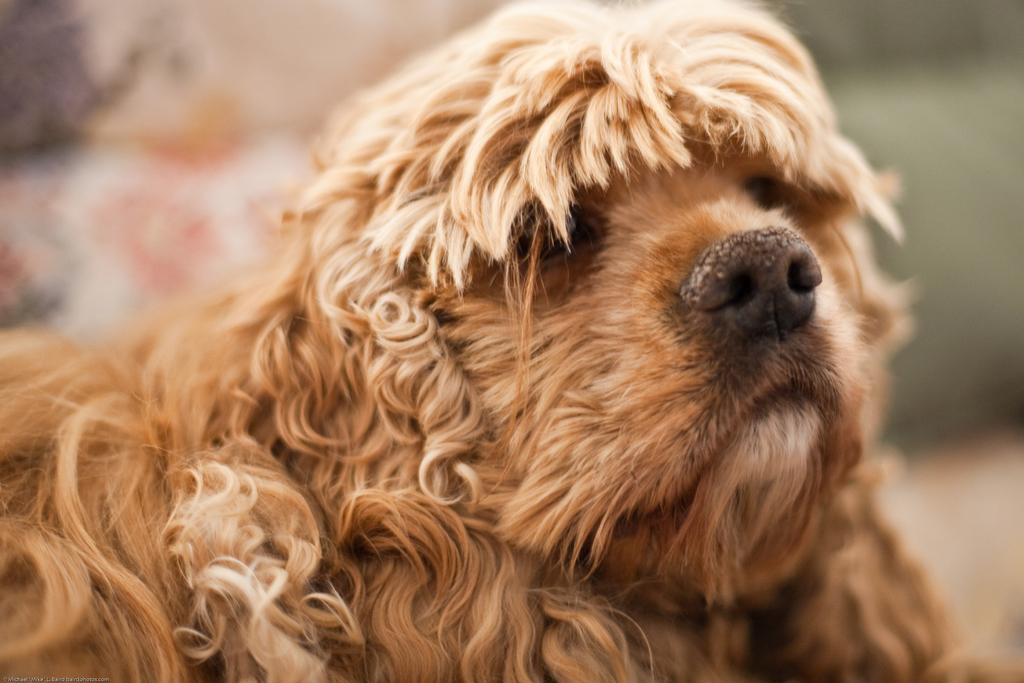What type of animal is in the image? There is a dog present in the image. What color is the dog? The dog is brown in color. Can you describe the background of the image? The background of the image is blurred. What invention is the dog using in the image? There is no invention present in the image; it is a dog in a blurred background. What type of glove is the dog wearing in the image? There is no glove present in the image; it is a dog with a brown color. 